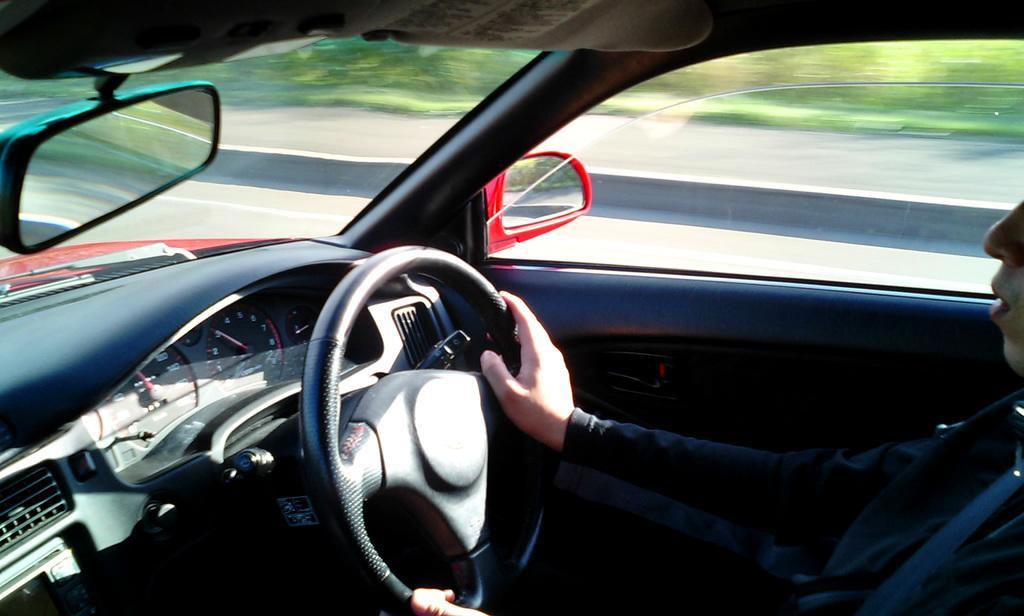Could you give a brief overview of what you see in this image? This is a picture of inside of a vehicle, in this image there is one person who is sitting and he is driving the vehicle. In front of him there is a steering, speed meters and some objects and mirrors, glass doors and through the doors we could see some trees and walkway. 